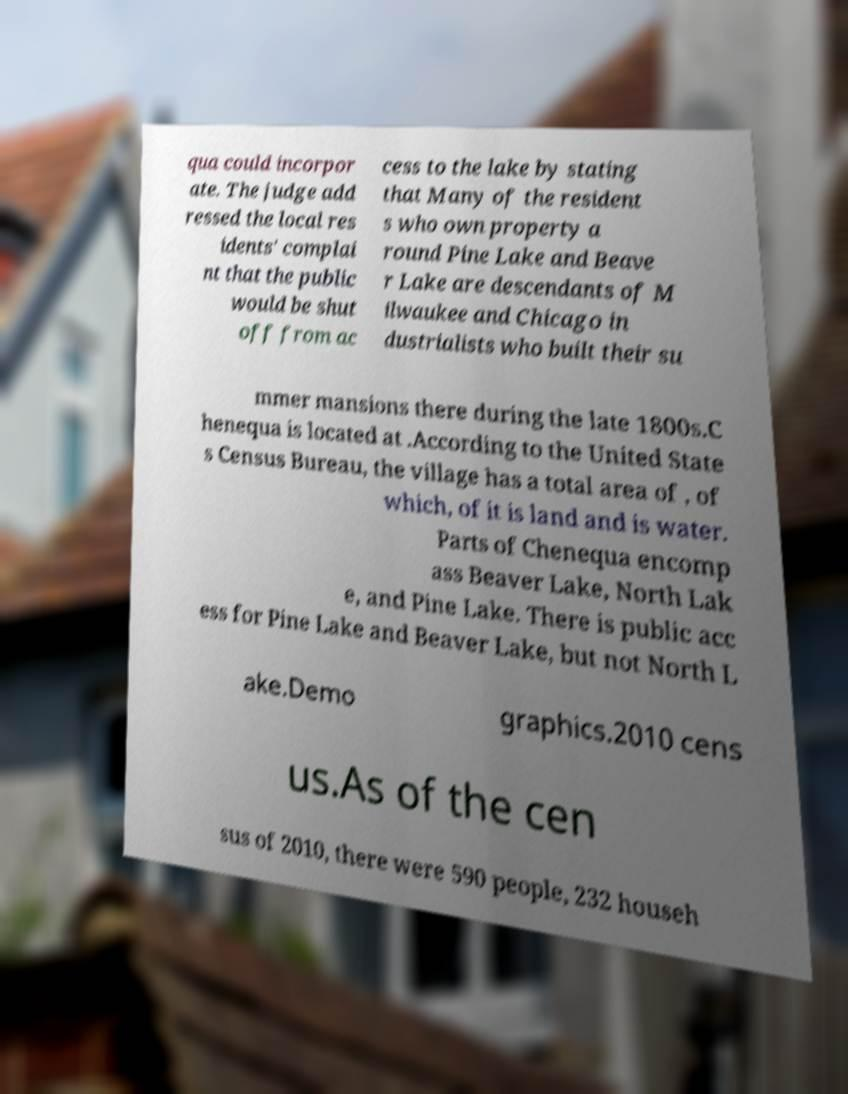Please read and relay the text visible in this image. What does it say? qua could incorpor ate. The judge add ressed the local res idents' complai nt that the public would be shut off from ac cess to the lake by stating that Many of the resident s who own property a round Pine Lake and Beave r Lake are descendants of M ilwaukee and Chicago in dustrialists who built their su mmer mansions there during the late 1800s.C henequa is located at .According to the United State s Census Bureau, the village has a total area of , of which, of it is land and is water. Parts of Chenequa encomp ass Beaver Lake, North Lak e, and Pine Lake. There is public acc ess for Pine Lake and Beaver Lake, but not North L ake.Demo graphics.2010 cens us.As of the cen sus of 2010, there were 590 people, 232 househ 